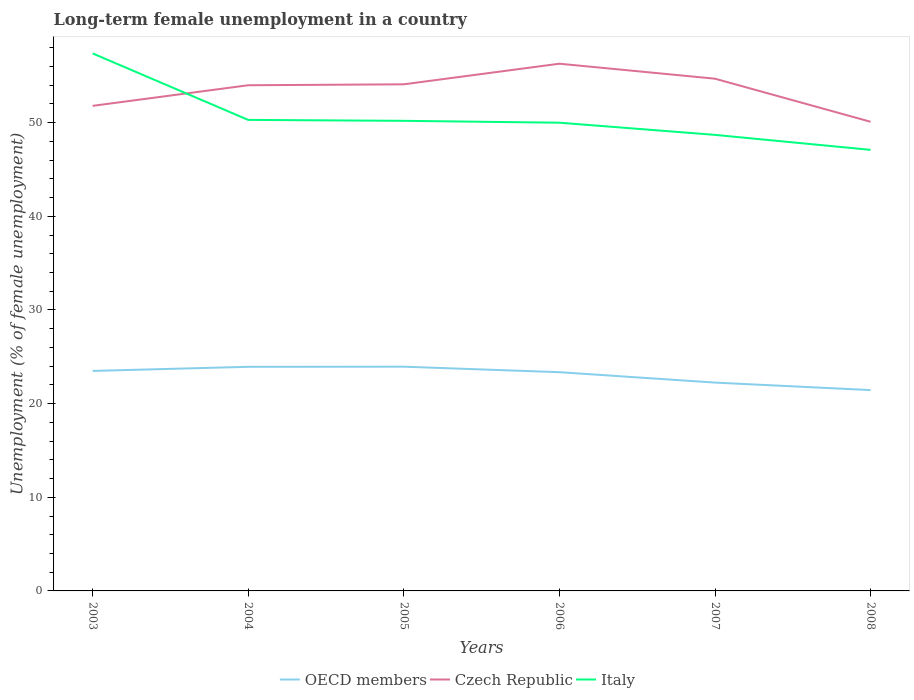Across all years, what is the maximum percentage of long-term unemployed female population in OECD members?
Your answer should be compact. 21.45. In which year was the percentage of long-term unemployed female population in OECD members maximum?
Make the answer very short. 2008. What is the total percentage of long-term unemployed female population in Italy in the graph?
Make the answer very short. 1.6. What is the difference between the highest and the second highest percentage of long-term unemployed female population in Italy?
Keep it short and to the point. 10.3. Is the percentage of long-term unemployed female population in OECD members strictly greater than the percentage of long-term unemployed female population in Italy over the years?
Make the answer very short. Yes. How many lines are there?
Offer a terse response. 3. Does the graph contain grids?
Ensure brevity in your answer.  No. Where does the legend appear in the graph?
Give a very brief answer. Bottom center. How are the legend labels stacked?
Make the answer very short. Horizontal. What is the title of the graph?
Offer a very short reply. Long-term female unemployment in a country. What is the label or title of the Y-axis?
Make the answer very short. Unemployment (% of female unemployment). What is the Unemployment (% of female unemployment) of OECD members in 2003?
Offer a terse response. 23.49. What is the Unemployment (% of female unemployment) in Czech Republic in 2003?
Make the answer very short. 51.8. What is the Unemployment (% of female unemployment) of Italy in 2003?
Provide a short and direct response. 57.4. What is the Unemployment (% of female unemployment) in OECD members in 2004?
Ensure brevity in your answer.  23.93. What is the Unemployment (% of female unemployment) of Italy in 2004?
Keep it short and to the point. 50.3. What is the Unemployment (% of female unemployment) in OECD members in 2005?
Your answer should be compact. 23.95. What is the Unemployment (% of female unemployment) in Czech Republic in 2005?
Offer a very short reply. 54.1. What is the Unemployment (% of female unemployment) in Italy in 2005?
Provide a short and direct response. 50.2. What is the Unemployment (% of female unemployment) in OECD members in 2006?
Make the answer very short. 23.36. What is the Unemployment (% of female unemployment) of Czech Republic in 2006?
Your answer should be very brief. 56.3. What is the Unemployment (% of female unemployment) in OECD members in 2007?
Your answer should be very brief. 22.25. What is the Unemployment (% of female unemployment) of Czech Republic in 2007?
Offer a terse response. 54.7. What is the Unemployment (% of female unemployment) in Italy in 2007?
Provide a succinct answer. 48.7. What is the Unemployment (% of female unemployment) of OECD members in 2008?
Offer a terse response. 21.45. What is the Unemployment (% of female unemployment) in Czech Republic in 2008?
Offer a terse response. 50.1. What is the Unemployment (% of female unemployment) in Italy in 2008?
Offer a very short reply. 47.1. Across all years, what is the maximum Unemployment (% of female unemployment) in OECD members?
Provide a succinct answer. 23.95. Across all years, what is the maximum Unemployment (% of female unemployment) in Czech Republic?
Your answer should be compact. 56.3. Across all years, what is the maximum Unemployment (% of female unemployment) in Italy?
Provide a short and direct response. 57.4. Across all years, what is the minimum Unemployment (% of female unemployment) in OECD members?
Keep it short and to the point. 21.45. Across all years, what is the minimum Unemployment (% of female unemployment) in Czech Republic?
Your answer should be very brief. 50.1. Across all years, what is the minimum Unemployment (% of female unemployment) in Italy?
Your answer should be very brief. 47.1. What is the total Unemployment (% of female unemployment) in OECD members in the graph?
Your response must be concise. 138.42. What is the total Unemployment (% of female unemployment) of Czech Republic in the graph?
Your answer should be compact. 321. What is the total Unemployment (% of female unemployment) in Italy in the graph?
Make the answer very short. 303.7. What is the difference between the Unemployment (% of female unemployment) in OECD members in 2003 and that in 2004?
Provide a short and direct response. -0.44. What is the difference between the Unemployment (% of female unemployment) in Czech Republic in 2003 and that in 2004?
Your answer should be compact. -2.2. What is the difference between the Unemployment (% of female unemployment) in Italy in 2003 and that in 2004?
Provide a succinct answer. 7.1. What is the difference between the Unemployment (% of female unemployment) of OECD members in 2003 and that in 2005?
Make the answer very short. -0.45. What is the difference between the Unemployment (% of female unemployment) in OECD members in 2003 and that in 2006?
Ensure brevity in your answer.  0.13. What is the difference between the Unemployment (% of female unemployment) of Czech Republic in 2003 and that in 2006?
Provide a succinct answer. -4.5. What is the difference between the Unemployment (% of female unemployment) in Italy in 2003 and that in 2006?
Your response must be concise. 7.4. What is the difference between the Unemployment (% of female unemployment) of OECD members in 2003 and that in 2007?
Your answer should be very brief. 1.25. What is the difference between the Unemployment (% of female unemployment) of Czech Republic in 2003 and that in 2007?
Keep it short and to the point. -2.9. What is the difference between the Unemployment (% of female unemployment) of OECD members in 2003 and that in 2008?
Make the answer very short. 2.05. What is the difference between the Unemployment (% of female unemployment) of Italy in 2003 and that in 2008?
Ensure brevity in your answer.  10.3. What is the difference between the Unemployment (% of female unemployment) in OECD members in 2004 and that in 2005?
Your answer should be very brief. -0.01. What is the difference between the Unemployment (% of female unemployment) of OECD members in 2004 and that in 2006?
Your response must be concise. 0.57. What is the difference between the Unemployment (% of female unemployment) of Italy in 2004 and that in 2006?
Ensure brevity in your answer.  0.3. What is the difference between the Unemployment (% of female unemployment) in OECD members in 2004 and that in 2007?
Your answer should be very brief. 1.68. What is the difference between the Unemployment (% of female unemployment) of Italy in 2004 and that in 2007?
Your response must be concise. 1.6. What is the difference between the Unemployment (% of female unemployment) in OECD members in 2004 and that in 2008?
Ensure brevity in your answer.  2.49. What is the difference between the Unemployment (% of female unemployment) in Czech Republic in 2004 and that in 2008?
Ensure brevity in your answer.  3.9. What is the difference between the Unemployment (% of female unemployment) in Italy in 2004 and that in 2008?
Ensure brevity in your answer.  3.2. What is the difference between the Unemployment (% of female unemployment) in OECD members in 2005 and that in 2006?
Your answer should be compact. 0.59. What is the difference between the Unemployment (% of female unemployment) in OECD members in 2005 and that in 2007?
Your answer should be very brief. 1.7. What is the difference between the Unemployment (% of female unemployment) of OECD members in 2006 and that in 2007?
Keep it short and to the point. 1.11. What is the difference between the Unemployment (% of female unemployment) of Italy in 2006 and that in 2007?
Provide a succinct answer. 1.3. What is the difference between the Unemployment (% of female unemployment) of OECD members in 2006 and that in 2008?
Give a very brief answer. 1.91. What is the difference between the Unemployment (% of female unemployment) of OECD members in 2007 and that in 2008?
Provide a short and direct response. 0.8. What is the difference between the Unemployment (% of female unemployment) in Italy in 2007 and that in 2008?
Give a very brief answer. 1.6. What is the difference between the Unemployment (% of female unemployment) of OECD members in 2003 and the Unemployment (% of female unemployment) of Czech Republic in 2004?
Your answer should be compact. -30.51. What is the difference between the Unemployment (% of female unemployment) in OECD members in 2003 and the Unemployment (% of female unemployment) in Italy in 2004?
Your response must be concise. -26.81. What is the difference between the Unemployment (% of female unemployment) of OECD members in 2003 and the Unemployment (% of female unemployment) of Czech Republic in 2005?
Offer a very short reply. -30.61. What is the difference between the Unemployment (% of female unemployment) in OECD members in 2003 and the Unemployment (% of female unemployment) in Italy in 2005?
Provide a short and direct response. -26.71. What is the difference between the Unemployment (% of female unemployment) of Czech Republic in 2003 and the Unemployment (% of female unemployment) of Italy in 2005?
Make the answer very short. 1.6. What is the difference between the Unemployment (% of female unemployment) of OECD members in 2003 and the Unemployment (% of female unemployment) of Czech Republic in 2006?
Provide a succinct answer. -32.81. What is the difference between the Unemployment (% of female unemployment) in OECD members in 2003 and the Unemployment (% of female unemployment) in Italy in 2006?
Keep it short and to the point. -26.51. What is the difference between the Unemployment (% of female unemployment) in Czech Republic in 2003 and the Unemployment (% of female unemployment) in Italy in 2006?
Make the answer very short. 1.8. What is the difference between the Unemployment (% of female unemployment) in OECD members in 2003 and the Unemployment (% of female unemployment) in Czech Republic in 2007?
Offer a terse response. -31.21. What is the difference between the Unemployment (% of female unemployment) in OECD members in 2003 and the Unemployment (% of female unemployment) in Italy in 2007?
Make the answer very short. -25.21. What is the difference between the Unemployment (% of female unemployment) of Czech Republic in 2003 and the Unemployment (% of female unemployment) of Italy in 2007?
Make the answer very short. 3.1. What is the difference between the Unemployment (% of female unemployment) in OECD members in 2003 and the Unemployment (% of female unemployment) in Czech Republic in 2008?
Ensure brevity in your answer.  -26.61. What is the difference between the Unemployment (% of female unemployment) of OECD members in 2003 and the Unemployment (% of female unemployment) of Italy in 2008?
Provide a short and direct response. -23.61. What is the difference between the Unemployment (% of female unemployment) of Czech Republic in 2003 and the Unemployment (% of female unemployment) of Italy in 2008?
Provide a succinct answer. 4.7. What is the difference between the Unemployment (% of female unemployment) of OECD members in 2004 and the Unemployment (% of female unemployment) of Czech Republic in 2005?
Offer a terse response. -30.17. What is the difference between the Unemployment (% of female unemployment) of OECD members in 2004 and the Unemployment (% of female unemployment) of Italy in 2005?
Offer a terse response. -26.27. What is the difference between the Unemployment (% of female unemployment) in Czech Republic in 2004 and the Unemployment (% of female unemployment) in Italy in 2005?
Give a very brief answer. 3.8. What is the difference between the Unemployment (% of female unemployment) of OECD members in 2004 and the Unemployment (% of female unemployment) of Czech Republic in 2006?
Your response must be concise. -32.37. What is the difference between the Unemployment (% of female unemployment) of OECD members in 2004 and the Unemployment (% of female unemployment) of Italy in 2006?
Provide a short and direct response. -26.07. What is the difference between the Unemployment (% of female unemployment) of Czech Republic in 2004 and the Unemployment (% of female unemployment) of Italy in 2006?
Provide a succinct answer. 4. What is the difference between the Unemployment (% of female unemployment) of OECD members in 2004 and the Unemployment (% of female unemployment) of Czech Republic in 2007?
Your answer should be very brief. -30.77. What is the difference between the Unemployment (% of female unemployment) of OECD members in 2004 and the Unemployment (% of female unemployment) of Italy in 2007?
Provide a short and direct response. -24.77. What is the difference between the Unemployment (% of female unemployment) in Czech Republic in 2004 and the Unemployment (% of female unemployment) in Italy in 2007?
Ensure brevity in your answer.  5.3. What is the difference between the Unemployment (% of female unemployment) in OECD members in 2004 and the Unemployment (% of female unemployment) in Czech Republic in 2008?
Offer a terse response. -26.17. What is the difference between the Unemployment (% of female unemployment) of OECD members in 2004 and the Unemployment (% of female unemployment) of Italy in 2008?
Provide a short and direct response. -23.17. What is the difference between the Unemployment (% of female unemployment) of Czech Republic in 2004 and the Unemployment (% of female unemployment) of Italy in 2008?
Provide a short and direct response. 6.9. What is the difference between the Unemployment (% of female unemployment) in OECD members in 2005 and the Unemployment (% of female unemployment) in Czech Republic in 2006?
Offer a terse response. -32.35. What is the difference between the Unemployment (% of female unemployment) of OECD members in 2005 and the Unemployment (% of female unemployment) of Italy in 2006?
Your answer should be compact. -26.05. What is the difference between the Unemployment (% of female unemployment) of OECD members in 2005 and the Unemployment (% of female unemployment) of Czech Republic in 2007?
Make the answer very short. -30.75. What is the difference between the Unemployment (% of female unemployment) in OECD members in 2005 and the Unemployment (% of female unemployment) in Italy in 2007?
Provide a short and direct response. -24.75. What is the difference between the Unemployment (% of female unemployment) of Czech Republic in 2005 and the Unemployment (% of female unemployment) of Italy in 2007?
Provide a succinct answer. 5.4. What is the difference between the Unemployment (% of female unemployment) in OECD members in 2005 and the Unemployment (% of female unemployment) in Czech Republic in 2008?
Provide a short and direct response. -26.15. What is the difference between the Unemployment (% of female unemployment) of OECD members in 2005 and the Unemployment (% of female unemployment) of Italy in 2008?
Your answer should be very brief. -23.15. What is the difference between the Unemployment (% of female unemployment) of Czech Republic in 2005 and the Unemployment (% of female unemployment) of Italy in 2008?
Ensure brevity in your answer.  7. What is the difference between the Unemployment (% of female unemployment) in OECD members in 2006 and the Unemployment (% of female unemployment) in Czech Republic in 2007?
Your answer should be compact. -31.34. What is the difference between the Unemployment (% of female unemployment) in OECD members in 2006 and the Unemployment (% of female unemployment) in Italy in 2007?
Keep it short and to the point. -25.34. What is the difference between the Unemployment (% of female unemployment) of Czech Republic in 2006 and the Unemployment (% of female unemployment) of Italy in 2007?
Give a very brief answer. 7.6. What is the difference between the Unemployment (% of female unemployment) of OECD members in 2006 and the Unemployment (% of female unemployment) of Czech Republic in 2008?
Keep it short and to the point. -26.74. What is the difference between the Unemployment (% of female unemployment) in OECD members in 2006 and the Unemployment (% of female unemployment) in Italy in 2008?
Give a very brief answer. -23.74. What is the difference between the Unemployment (% of female unemployment) in Czech Republic in 2006 and the Unemployment (% of female unemployment) in Italy in 2008?
Ensure brevity in your answer.  9.2. What is the difference between the Unemployment (% of female unemployment) of OECD members in 2007 and the Unemployment (% of female unemployment) of Czech Republic in 2008?
Offer a terse response. -27.85. What is the difference between the Unemployment (% of female unemployment) in OECD members in 2007 and the Unemployment (% of female unemployment) in Italy in 2008?
Offer a terse response. -24.85. What is the average Unemployment (% of female unemployment) of OECD members per year?
Your answer should be compact. 23.07. What is the average Unemployment (% of female unemployment) of Czech Republic per year?
Offer a terse response. 53.5. What is the average Unemployment (% of female unemployment) in Italy per year?
Offer a very short reply. 50.62. In the year 2003, what is the difference between the Unemployment (% of female unemployment) in OECD members and Unemployment (% of female unemployment) in Czech Republic?
Provide a short and direct response. -28.31. In the year 2003, what is the difference between the Unemployment (% of female unemployment) of OECD members and Unemployment (% of female unemployment) of Italy?
Your answer should be very brief. -33.91. In the year 2003, what is the difference between the Unemployment (% of female unemployment) of Czech Republic and Unemployment (% of female unemployment) of Italy?
Ensure brevity in your answer.  -5.6. In the year 2004, what is the difference between the Unemployment (% of female unemployment) in OECD members and Unemployment (% of female unemployment) in Czech Republic?
Offer a terse response. -30.07. In the year 2004, what is the difference between the Unemployment (% of female unemployment) in OECD members and Unemployment (% of female unemployment) in Italy?
Provide a short and direct response. -26.37. In the year 2004, what is the difference between the Unemployment (% of female unemployment) of Czech Republic and Unemployment (% of female unemployment) of Italy?
Your answer should be very brief. 3.7. In the year 2005, what is the difference between the Unemployment (% of female unemployment) in OECD members and Unemployment (% of female unemployment) in Czech Republic?
Ensure brevity in your answer.  -30.15. In the year 2005, what is the difference between the Unemployment (% of female unemployment) of OECD members and Unemployment (% of female unemployment) of Italy?
Offer a very short reply. -26.25. In the year 2005, what is the difference between the Unemployment (% of female unemployment) of Czech Republic and Unemployment (% of female unemployment) of Italy?
Make the answer very short. 3.9. In the year 2006, what is the difference between the Unemployment (% of female unemployment) of OECD members and Unemployment (% of female unemployment) of Czech Republic?
Provide a short and direct response. -32.94. In the year 2006, what is the difference between the Unemployment (% of female unemployment) in OECD members and Unemployment (% of female unemployment) in Italy?
Provide a short and direct response. -26.64. In the year 2006, what is the difference between the Unemployment (% of female unemployment) in Czech Republic and Unemployment (% of female unemployment) in Italy?
Offer a terse response. 6.3. In the year 2007, what is the difference between the Unemployment (% of female unemployment) in OECD members and Unemployment (% of female unemployment) in Czech Republic?
Provide a succinct answer. -32.45. In the year 2007, what is the difference between the Unemployment (% of female unemployment) of OECD members and Unemployment (% of female unemployment) of Italy?
Keep it short and to the point. -26.45. In the year 2008, what is the difference between the Unemployment (% of female unemployment) of OECD members and Unemployment (% of female unemployment) of Czech Republic?
Make the answer very short. -28.65. In the year 2008, what is the difference between the Unemployment (% of female unemployment) in OECD members and Unemployment (% of female unemployment) in Italy?
Offer a terse response. -25.65. What is the ratio of the Unemployment (% of female unemployment) in OECD members in 2003 to that in 2004?
Offer a terse response. 0.98. What is the ratio of the Unemployment (% of female unemployment) of Czech Republic in 2003 to that in 2004?
Provide a short and direct response. 0.96. What is the ratio of the Unemployment (% of female unemployment) in Italy in 2003 to that in 2004?
Make the answer very short. 1.14. What is the ratio of the Unemployment (% of female unemployment) of OECD members in 2003 to that in 2005?
Your response must be concise. 0.98. What is the ratio of the Unemployment (% of female unemployment) in Czech Republic in 2003 to that in 2005?
Provide a short and direct response. 0.96. What is the ratio of the Unemployment (% of female unemployment) of Italy in 2003 to that in 2005?
Your response must be concise. 1.14. What is the ratio of the Unemployment (% of female unemployment) in OECD members in 2003 to that in 2006?
Your response must be concise. 1.01. What is the ratio of the Unemployment (% of female unemployment) in Czech Republic in 2003 to that in 2006?
Ensure brevity in your answer.  0.92. What is the ratio of the Unemployment (% of female unemployment) in Italy in 2003 to that in 2006?
Your response must be concise. 1.15. What is the ratio of the Unemployment (% of female unemployment) of OECD members in 2003 to that in 2007?
Offer a very short reply. 1.06. What is the ratio of the Unemployment (% of female unemployment) in Czech Republic in 2003 to that in 2007?
Offer a terse response. 0.95. What is the ratio of the Unemployment (% of female unemployment) in Italy in 2003 to that in 2007?
Provide a short and direct response. 1.18. What is the ratio of the Unemployment (% of female unemployment) in OECD members in 2003 to that in 2008?
Offer a terse response. 1.1. What is the ratio of the Unemployment (% of female unemployment) in Czech Republic in 2003 to that in 2008?
Provide a succinct answer. 1.03. What is the ratio of the Unemployment (% of female unemployment) of Italy in 2003 to that in 2008?
Give a very brief answer. 1.22. What is the ratio of the Unemployment (% of female unemployment) in Czech Republic in 2004 to that in 2005?
Provide a succinct answer. 1. What is the ratio of the Unemployment (% of female unemployment) in OECD members in 2004 to that in 2006?
Ensure brevity in your answer.  1.02. What is the ratio of the Unemployment (% of female unemployment) in Czech Republic in 2004 to that in 2006?
Offer a terse response. 0.96. What is the ratio of the Unemployment (% of female unemployment) of Italy in 2004 to that in 2006?
Keep it short and to the point. 1.01. What is the ratio of the Unemployment (% of female unemployment) of OECD members in 2004 to that in 2007?
Ensure brevity in your answer.  1.08. What is the ratio of the Unemployment (% of female unemployment) in Czech Republic in 2004 to that in 2007?
Your response must be concise. 0.99. What is the ratio of the Unemployment (% of female unemployment) of Italy in 2004 to that in 2007?
Offer a terse response. 1.03. What is the ratio of the Unemployment (% of female unemployment) of OECD members in 2004 to that in 2008?
Offer a terse response. 1.12. What is the ratio of the Unemployment (% of female unemployment) in Czech Republic in 2004 to that in 2008?
Your answer should be compact. 1.08. What is the ratio of the Unemployment (% of female unemployment) of Italy in 2004 to that in 2008?
Provide a short and direct response. 1.07. What is the ratio of the Unemployment (% of female unemployment) in OECD members in 2005 to that in 2006?
Your answer should be very brief. 1.03. What is the ratio of the Unemployment (% of female unemployment) in Czech Republic in 2005 to that in 2006?
Offer a very short reply. 0.96. What is the ratio of the Unemployment (% of female unemployment) of OECD members in 2005 to that in 2007?
Provide a succinct answer. 1.08. What is the ratio of the Unemployment (% of female unemployment) of Czech Republic in 2005 to that in 2007?
Give a very brief answer. 0.99. What is the ratio of the Unemployment (% of female unemployment) in Italy in 2005 to that in 2007?
Your response must be concise. 1.03. What is the ratio of the Unemployment (% of female unemployment) in OECD members in 2005 to that in 2008?
Your answer should be very brief. 1.12. What is the ratio of the Unemployment (% of female unemployment) of Czech Republic in 2005 to that in 2008?
Give a very brief answer. 1.08. What is the ratio of the Unemployment (% of female unemployment) of Italy in 2005 to that in 2008?
Provide a short and direct response. 1.07. What is the ratio of the Unemployment (% of female unemployment) in OECD members in 2006 to that in 2007?
Offer a very short reply. 1.05. What is the ratio of the Unemployment (% of female unemployment) of Czech Republic in 2006 to that in 2007?
Your answer should be very brief. 1.03. What is the ratio of the Unemployment (% of female unemployment) of Italy in 2006 to that in 2007?
Your answer should be very brief. 1.03. What is the ratio of the Unemployment (% of female unemployment) in OECD members in 2006 to that in 2008?
Provide a succinct answer. 1.09. What is the ratio of the Unemployment (% of female unemployment) in Czech Republic in 2006 to that in 2008?
Keep it short and to the point. 1.12. What is the ratio of the Unemployment (% of female unemployment) in Italy in 2006 to that in 2008?
Offer a very short reply. 1.06. What is the ratio of the Unemployment (% of female unemployment) of OECD members in 2007 to that in 2008?
Your answer should be very brief. 1.04. What is the ratio of the Unemployment (% of female unemployment) of Czech Republic in 2007 to that in 2008?
Your answer should be very brief. 1.09. What is the ratio of the Unemployment (% of female unemployment) of Italy in 2007 to that in 2008?
Your answer should be very brief. 1.03. What is the difference between the highest and the second highest Unemployment (% of female unemployment) in OECD members?
Provide a succinct answer. 0.01. What is the difference between the highest and the second highest Unemployment (% of female unemployment) in Czech Republic?
Keep it short and to the point. 1.6. What is the difference between the highest and the lowest Unemployment (% of female unemployment) in OECD members?
Keep it short and to the point. 2.5. What is the difference between the highest and the lowest Unemployment (% of female unemployment) in Italy?
Your response must be concise. 10.3. 